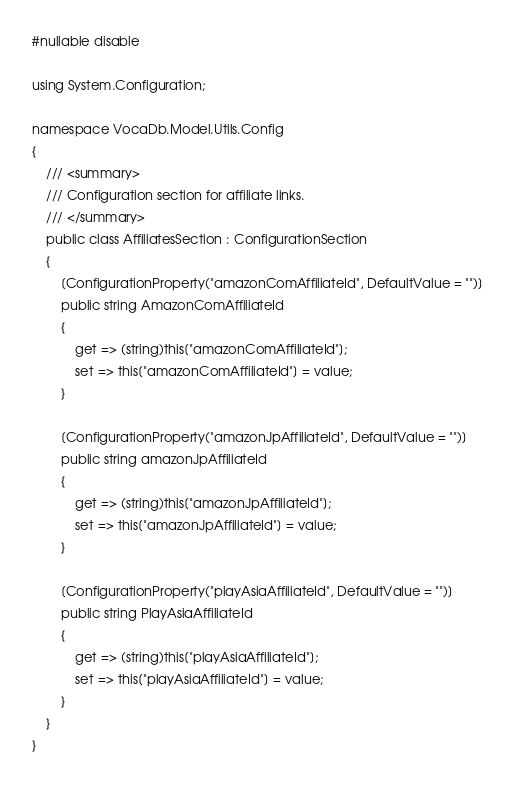Convert code to text. <code><loc_0><loc_0><loc_500><loc_500><_C#_>#nullable disable

using System.Configuration;

namespace VocaDb.Model.Utils.Config
{
	/// <summary>
	/// Configuration section for affiliate links.
	/// </summary>
	public class AffiliatesSection : ConfigurationSection
	{
		[ConfigurationProperty("amazonComAffiliateId", DefaultValue = "")]
		public string AmazonComAffiliateId
		{
			get => (string)this["amazonComAffiliateId"];
			set => this["amazonComAffiliateId"] = value;
		}

		[ConfigurationProperty("amazonJpAffiliateId", DefaultValue = "")]
		public string amazonJpAffiliateId
		{
			get => (string)this["amazonJpAffiliateId"];
			set => this["amazonJpAffiliateId"] = value;
		}

		[ConfigurationProperty("playAsiaAffiliateId", DefaultValue = "")]
		public string PlayAsiaAffiliateId
		{
			get => (string)this["playAsiaAffiliateId"];
			set => this["playAsiaAffiliateId"] = value;
		}
	}
}
</code> 